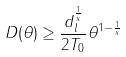<formula> <loc_0><loc_0><loc_500><loc_500>D ( \theta ) & \geq \frac { d _ { l } ^ { \frac { 1 } { x } } } { 2 T _ { 0 } } \theta ^ { 1 - \frac { 1 } { x } }</formula> 